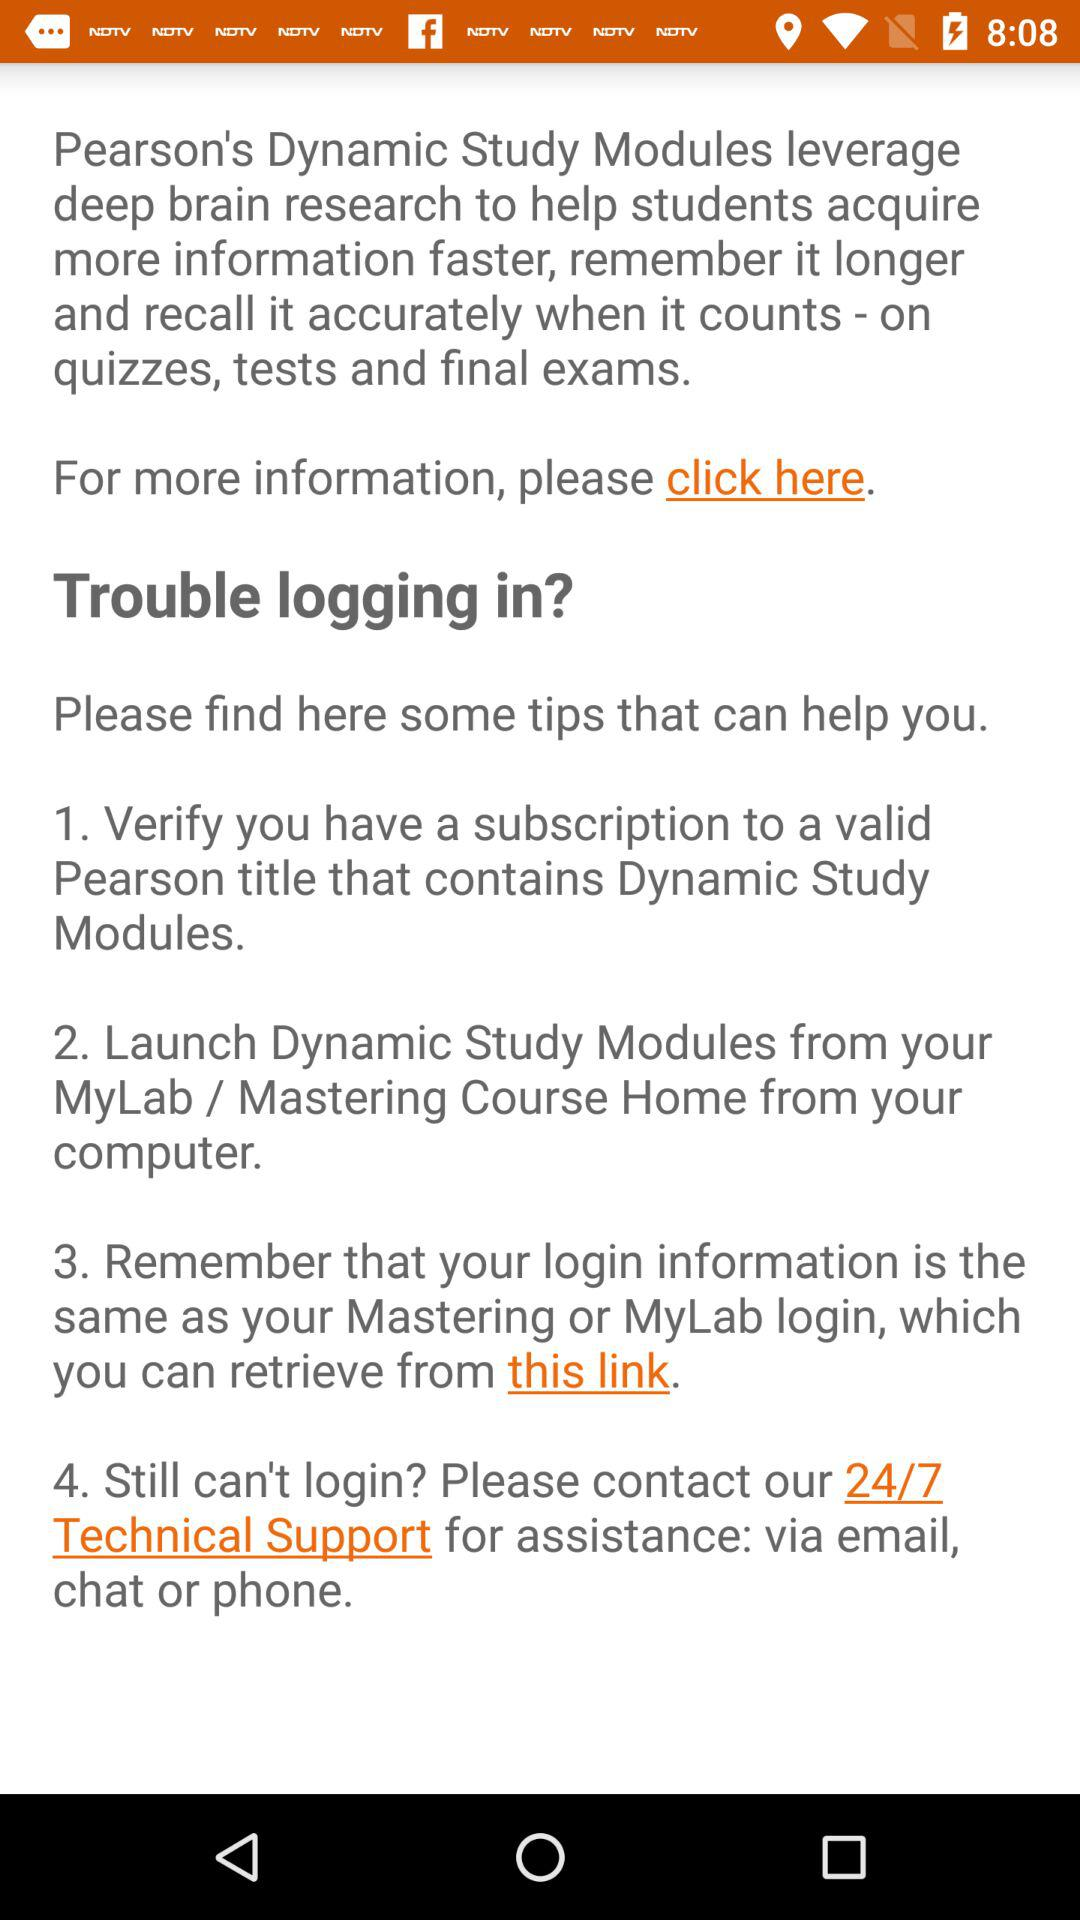How many steps are there to help troubleshoot logging in?
Answer the question using a single word or phrase. 4 